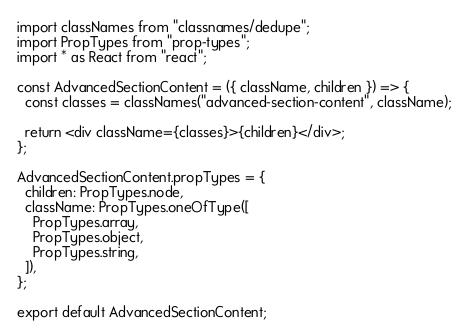<code> <loc_0><loc_0><loc_500><loc_500><_TypeScript_>import classNames from "classnames/dedupe";
import PropTypes from "prop-types";
import * as React from "react";

const AdvancedSectionContent = ({ className, children }) => {
  const classes = classNames("advanced-section-content", className);

  return <div className={classes}>{children}</div>;
};

AdvancedSectionContent.propTypes = {
  children: PropTypes.node,
  className: PropTypes.oneOfType([
    PropTypes.array,
    PropTypes.object,
    PropTypes.string,
  ]),
};

export default AdvancedSectionContent;
</code> 